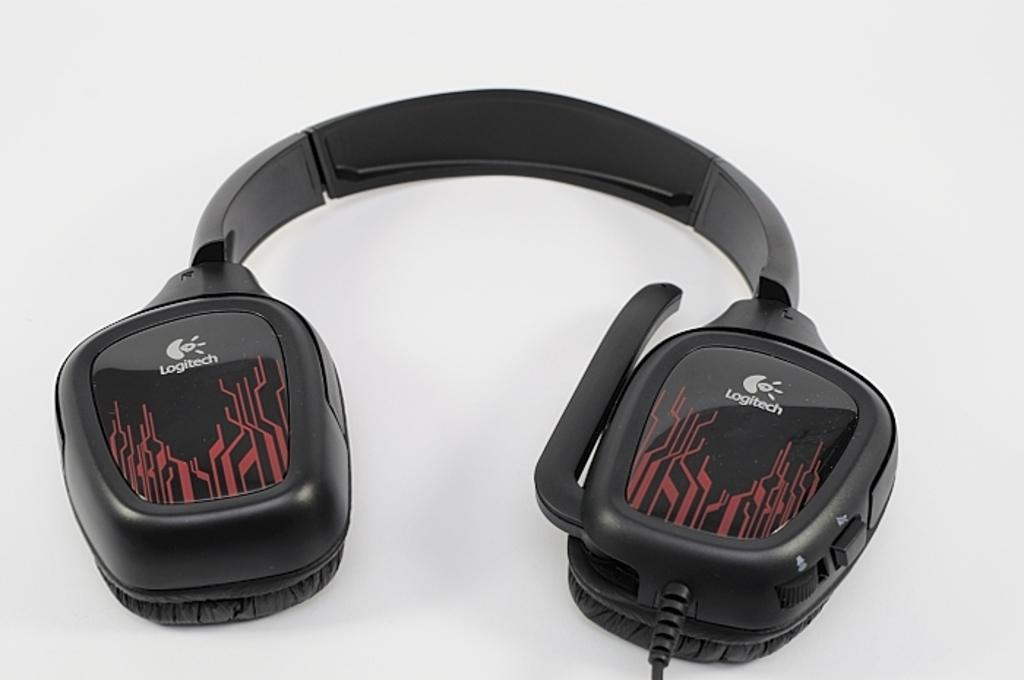Provide a one-sentence caption for the provided image. A pair of headphones with a graphic picture and the labeling LOGITECH on them. 